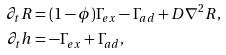<formula> <loc_0><loc_0><loc_500><loc_500>\partial _ { t } R & = ( 1 - \phi ) \Gamma _ { e x } - \Gamma _ { a d } + D \nabla ^ { 2 } R , \\ \partial _ { t } h & = - \Gamma _ { e x } + \Gamma _ { a d } ,</formula> 